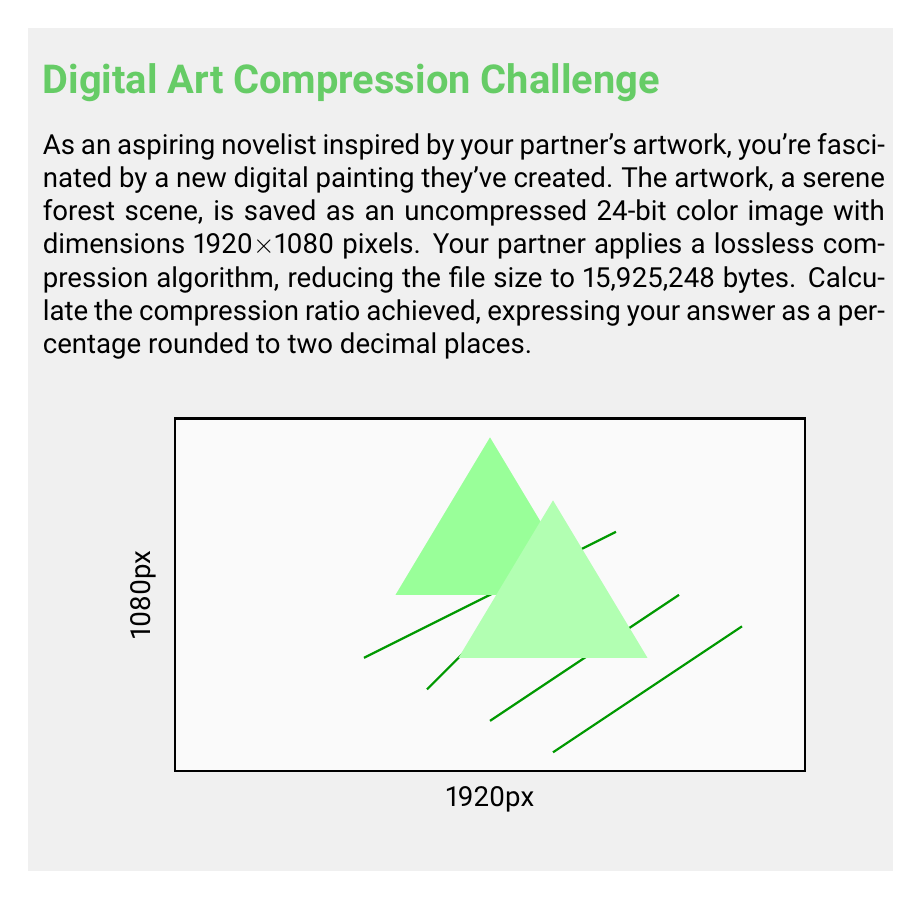Give your solution to this math problem. Let's approach this step-by-step:

1) First, we need to calculate the original file size:
   - Image dimensions: 1920 x 1080 pixels
   - Color depth: 24 bits per pixel
   
   Original file size = $1920 \times 1080 \times 24$ bits
                      = $49,766,400$ bits
                      = $49,766,400 \div 8$ bytes (since 1 byte = 8 bits)
                      = $6,220,800$ bytes

2) The compressed file size is given as 15,925,248 bytes.

3) The compression ratio is calculated using the formula:
   
   $\text{Compression Ratio} = (1 - \frac{\text{Compressed Size}}{\text{Original Size}}) \times 100\%$

4) Plugging in our values:

   $\text{Compression Ratio} = (1 - \frac{15,925,248}{6,220,800}) \times 100\%$

5) Simplifying:
   
   $= (1 - 2.5600) \times 100\%$
   $= -1.5600 \times 100\%$
   $= -156.00\%$

6) However, since we're dealing with compression, we need to take the absolute value:

   $\text{Compression Ratio} = |{-156.00\%}| = 156.00\%$

Therefore, the compression ratio achieved is 156.00%.
Answer: 156.00% 